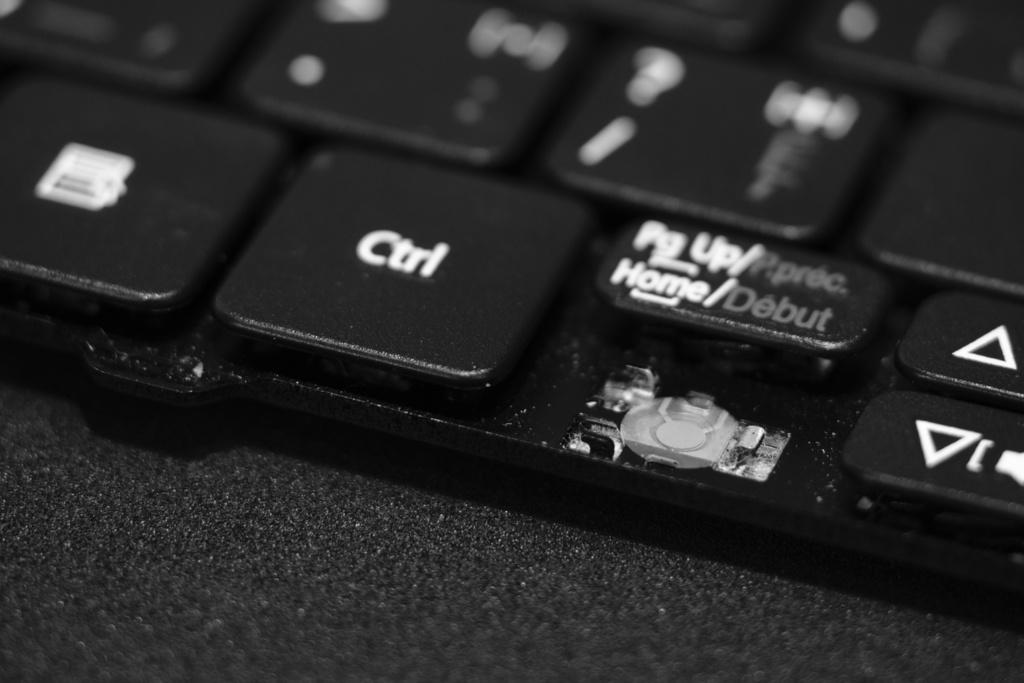<image>
Give a short and clear explanation of the subsequent image. a close up of a keyboard shows a CTRL key 